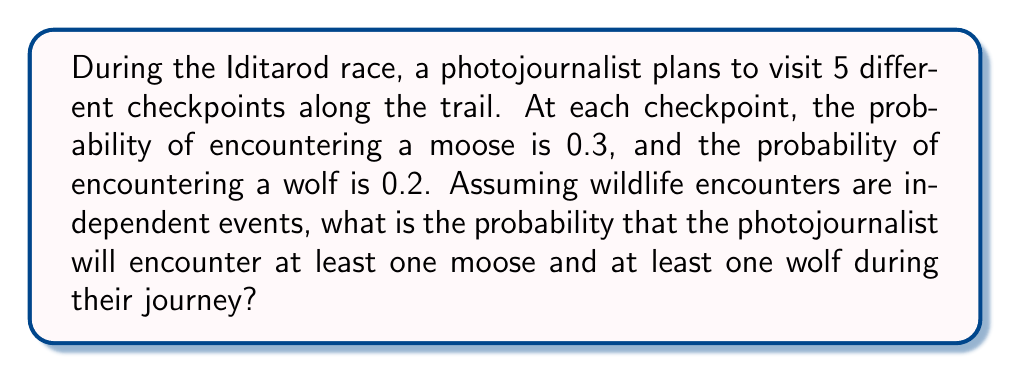Can you solve this math problem? Let's approach this step-by-step:

1) First, let's calculate the probability of not encountering a moose at a single checkpoint:
   $P(\text{no moose}) = 1 - 0.3 = 0.7$

2) The probability of not encountering a moose at all 5 checkpoints:
   $P(\text{no moose at all}) = 0.7^5 = 0.16807$

3) Therefore, the probability of encountering at least one moose:
   $P(\text{at least one moose}) = 1 - 0.16807 = 0.83193$

4) Similarly for wolves:
   $P(\text{no wolf}) = 1 - 0.2 = 0.8$
   $P(\text{no wolf at all}) = 0.8^5 = 0.32768$
   $P(\text{at least one wolf}) = 1 - 0.32768 = 0.67232$

5) The question asks for the probability of encountering at least one moose AND at least one wolf. Since these are independent events, we multiply these probabilities:

   $P(\text{at least one moose and at least one wolf}) = 0.83193 \times 0.67232 = 0.55932$

6) We can express this as a percentage: $0.55932 \times 100\% = 55.932\%$
Answer: $55.932\%$ 